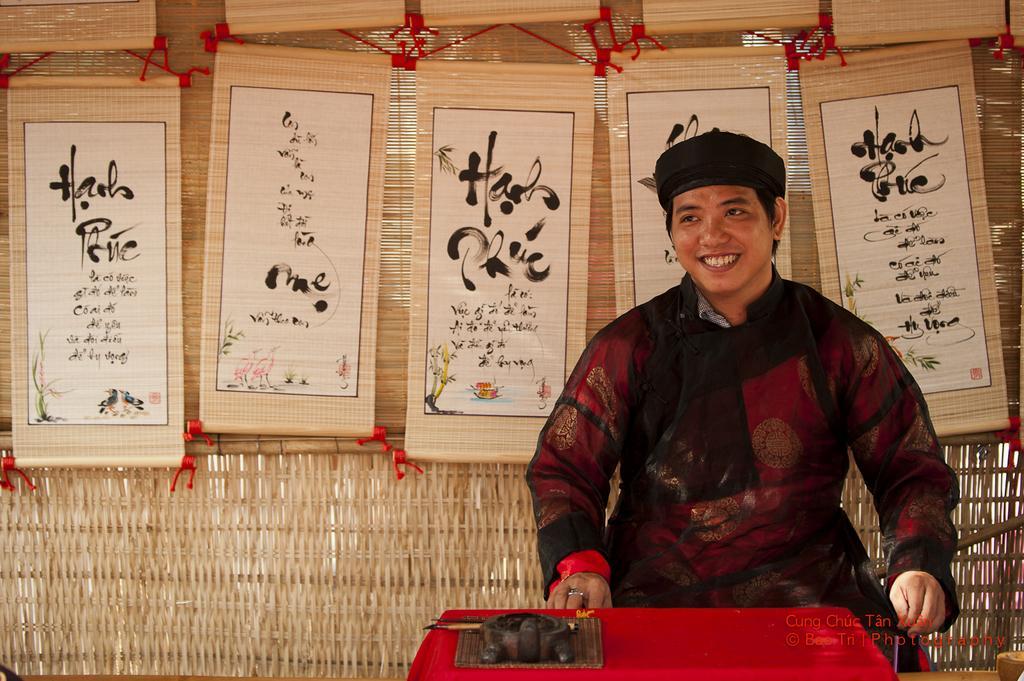How would you summarize this image in a sentence or two? In this image I can see a person smiling. There are scroll cards at the back. There is a table in the front. 